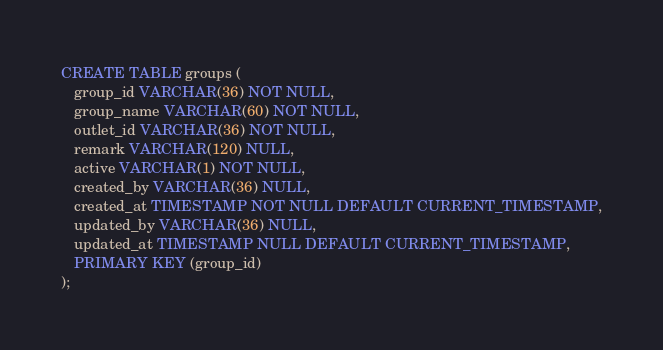<code> <loc_0><loc_0><loc_500><loc_500><_SQL_>CREATE TABLE groups (
   group_id VARCHAR(36) NOT NULL,
   group_name VARCHAR(60) NOT NULL,
   outlet_id VARCHAR(36) NOT NULL,
   remark VARCHAR(120) NULL,
   active VARCHAR(1) NOT NULL,
   created_by VARCHAR(36) NULL,
   created_at TIMESTAMP NOT NULL DEFAULT CURRENT_TIMESTAMP,
   updated_by VARCHAR(36) NULL,
   updated_at TIMESTAMP NULL DEFAULT CURRENT_TIMESTAMP,
   PRIMARY KEY (group_id)
);</code> 